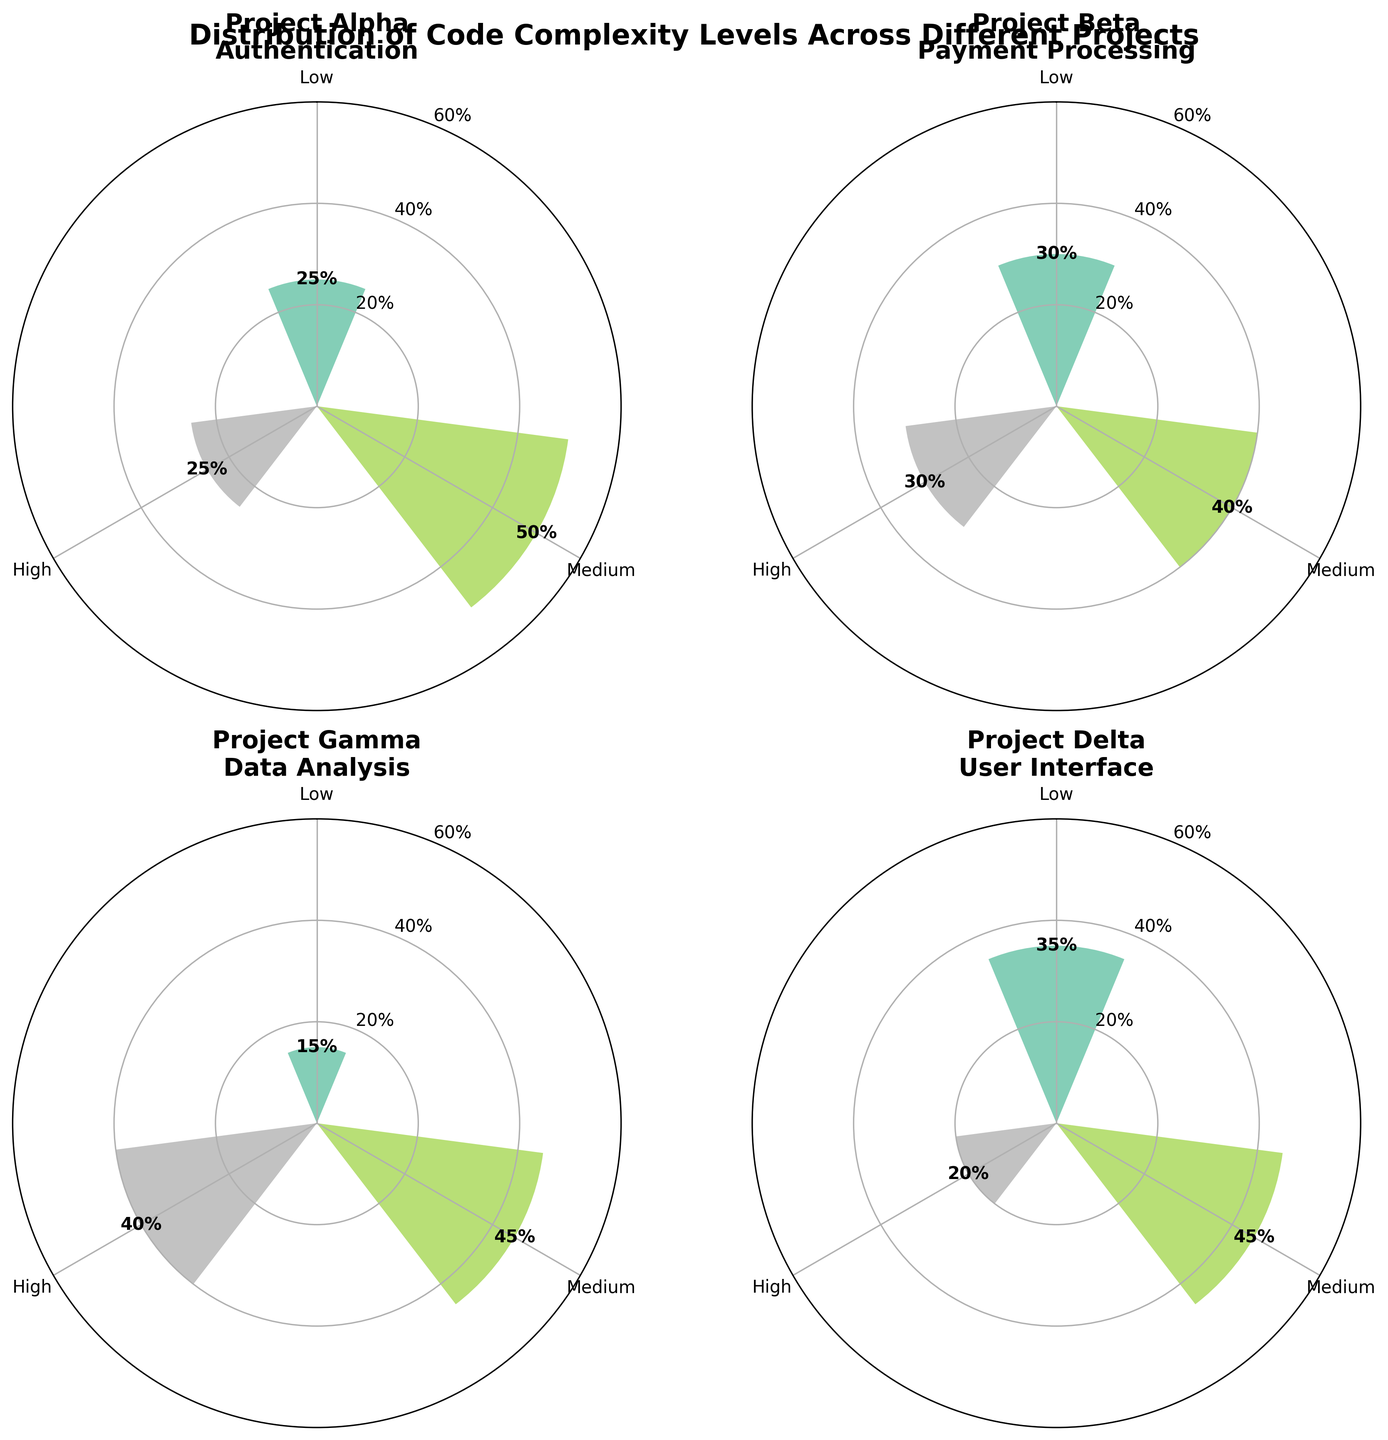What's the title of the figure? The title is displayed at the top center of the figure. It reads "Distribution of Code Complexity Levels Across Different Projects."
Answer: Distribution of Code Complexity Levels Across Different Projects Which project has the highest percentage of high complexity functions? In the subplots, the segment corresponding to the "High" complexity is largest for Project Gamma.
Answer: Project Gamma What is the sum of the percentages for the low complexity functions across all projects? The percentages for Low complexity are 25% (Project Alpha), 30% (Project Beta), 15% (Project Gamma), and 35% (Project Delta). Summing these: 25 + 30 + 15 + 35 = 105%
Answer: 105% Which project has the most balanced distribution between the complexity levels? Project Alpha has 25% low, 50% medium, and 25% high complexity, making its distribution more balanced compared to others.
Answer: Project Alpha What is the percentage difference between medium and high complexity functions in Project Beta? For Project Beta, medium complexity is 40% and high complexity is 30%. The difference is 40 - 30 = 10%.
Answer: 10% Which project has the smallest percentage for low complexity? Project Gamma shows the smallest segment for low complexity at 15%.
Answer: Project Gamma How many projects have a higher percentage of medium complexity functions than high complexity functions? Project Alpha (50% vs 25%), Project Beta (40% vs 30%), and Project Delta (45% vs 20%) have higher percentages of medium complexity than high complexity. Therefore, 3 projects meet the criteria.
Answer: 3 What is the average percentage of medium complexity functions across all projects? The percentages for medium complexity are 50% (Project Alpha), 40% (Project Beta), 45% (Project Gamma), and 45% (Project Delta). Summing these: 50 + 40 + 45 + 45 = 180, and the average is 180 / 4 = 45%.
Answer: 45% Which project has the largest percentage for medium complexity, and what is it? Both Project Delta and Project Alpha have the highest percentage for medium complexity at 45% and 50% respectively.
Answer: Project Alpha What is the total percentage of high complexity functions for Project Gamma and Project Delta combined? Project Gamma has 40% and Project Delta has 20% for high complexity. The total is 40 + 20 = 60%.
Answer: 60% 